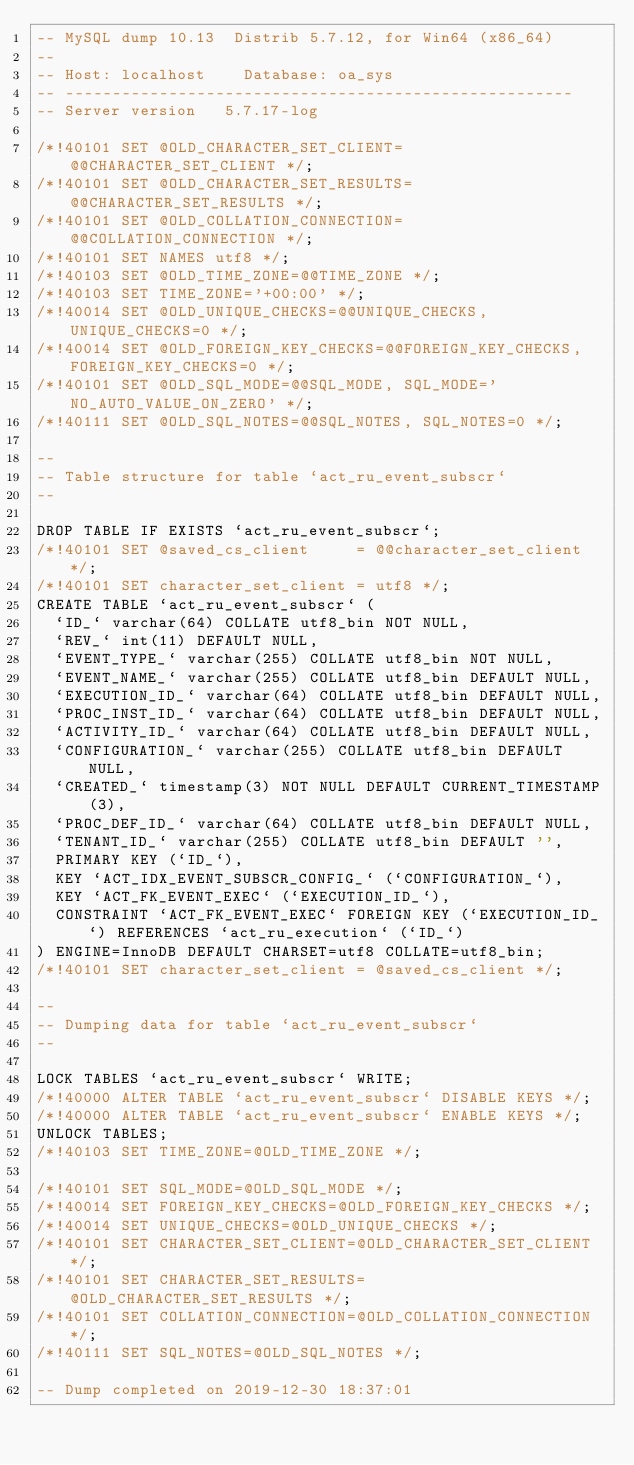Convert code to text. <code><loc_0><loc_0><loc_500><loc_500><_SQL_>-- MySQL dump 10.13  Distrib 5.7.12, for Win64 (x86_64)
--
-- Host: localhost    Database: oa_sys
-- ------------------------------------------------------
-- Server version	5.7.17-log

/*!40101 SET @OLD_CHARACTER_SET_CLIENT=@@CHARACTER_SET_CLIENT */;
/*!40101 SET @OLD_CHARACTER_SET_RESULTS=@@CHARACTER_SET_RESULTS */;
/*!40101 SET @OLD_COLLATION_CONNECTION=@@COLLATION_CONNECTION */;
/*!40101 SET NAMES utf8 */;
/*!40103 SET @OLD_TIME_ZONE=@@TIME_ZONE */;
/*!40103 SET TIME_ZONE='+00:00' */;
/*!40014 SET @OLD_UNIQUE_CHECKS=@@UNIQUE_CHECKS, UNIQUE_CHECKS=0 */;
/*!40014 SET @OLD_FOREIGN_KEY_CHECKS=@@FOREIGN_KEY_CHECKS, FOREIGN_KEY_CHECKS=0 */;
/*!40101 SET @OLD_SQL_MODE=@@SQL_MODE, SQL_MODE='NO_AUTO_VALUE_ON_ZERO' */;
/*!40111 SET @OLD_SQL_NOTES=@@SQL_NOTES, SQL_NOTES=0 */;

--
-- Table structure for table `act_ru_event_subscr`
--

DROP TABLE IF EXISTS `act_ru_event_subscr`;
/*!40101 SET @saved_cs_client     = @@character_set_client */;
/*!40101 SET character_set_client = utf8 */;
CREATE TABLE `act_ru_event_subscr` (
  `ID_` varchar(64) COLLATE utf8_bin NOT NULL,
  `REV_` int(11) DEFAULT NULL,
  `EVENT_TYPE_` varchar(255) COLLATE utf8_bin NOT NULL,
  `EVENT_NAME_` varchar(255) COLLATE utf8_bin DEFAULT NULL,
  `EXECUTION_ID_` varchar(64) COLLATE utf8_bin DEFAULT NULL,
  `PROC_INST_ID_` varchar(64) COLLATE utf8_bin DEFAULT NULL,
  `ACTIVITY_ID_` varchar(64) COLLATE utf8_bin DEFAULT NULL,
  `CONFIGURATION_` varchar(255) COLLATE utf8_bin DEFAULT NULL,
  `CREATED_` timestamp(3) NOT NULL DEFAULT CURRENT_TIMESTAMP(3),
  `PROC_DEF_ID_` varchar(64) COLLATE utf8_bin DEFAULT NULL,
  `TENANT_ID_` varchar(255) COLLATE utf8_bin DEFAULT '',
  PRIMARY KEY (`ID_`),
  KEY `ACT_IDX_EVENT_SUBSCR_CONFIG_` (`CONFIGURATION_`),
  KEY `ACT_FK_EVENT_EXEC` (`EXECUTION_ID_`),
  CONSTRAINT `ACT_FK_EVENT_EXEC` FOREIGN KEY (`EXECUTION_ID_`) REFERENCES `act_ru_execution` (`ID_`)
) ENGINE=InnoDB DEFAULT CHARSET=utf8 COLLATE=utf8_bin;
/*!40101 SET character_set_client = @saved_cs_client */;

--
-- Dumping data for table `act_ru_event_subscr`
--

LOCK TABLES `act_ru_event_subscr` WRITE;
/*!40000 ALTER TABLE `act_ru_event_subscr` DISABLE KEYS */;
/*!40000 ALTER TABLE `act_ru_event_subscr` ENABLE KEYS */;
UNLOCK TABLES;
/*!40103 SET TIME_ZONE=@OLD_TIME_ZONE */;

/*!40101 SET SQL_MODE=@OLD_SQL_MODE */;
/*!40014 SET FOREIGN_KEY_CHECKS=@OLD_FOREIGN_KEY_CHECKS */;
/*!40014 SET UNIQUE_CHECKS=@OLD_UNIQUE_CHECKS */;
/*!40101 SET CHARACTER_SET_CLIENT=@OLD_CHARACTER_SET_CLIENT */;
/*!40101 SET CHARACTER_SET_RESULTS=@OLD_CHARACTER_SET_RESULTS */;
/*!40101 SET COLLATION_CONNECTION=@OLD_COLLATION_CONNECTION */;
/*!40111 SET SQL_NOTES=@OLD_SQL_NOTES */;

-- Dump completed on 2019-12-30 18:37:01
</code> 